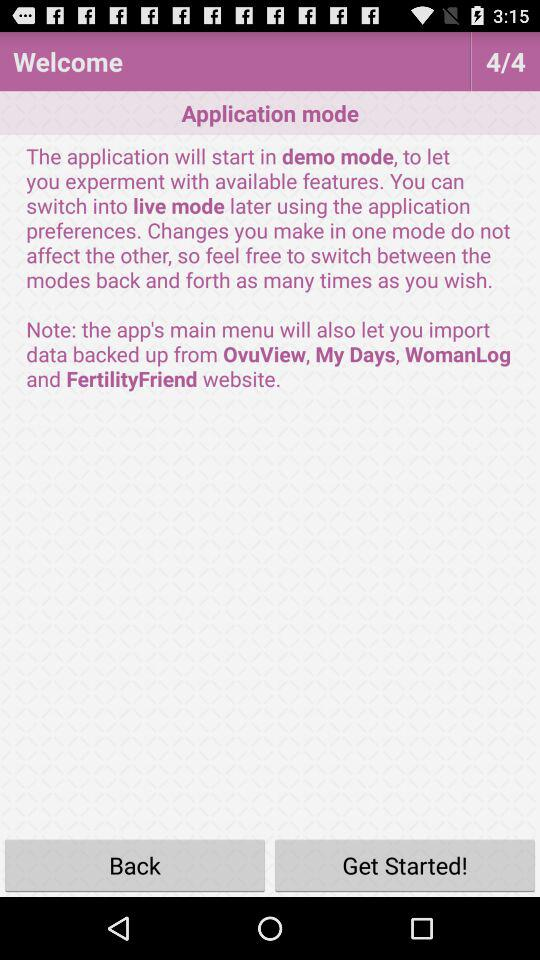In what mode will the application start? The application will start in demo mode. 